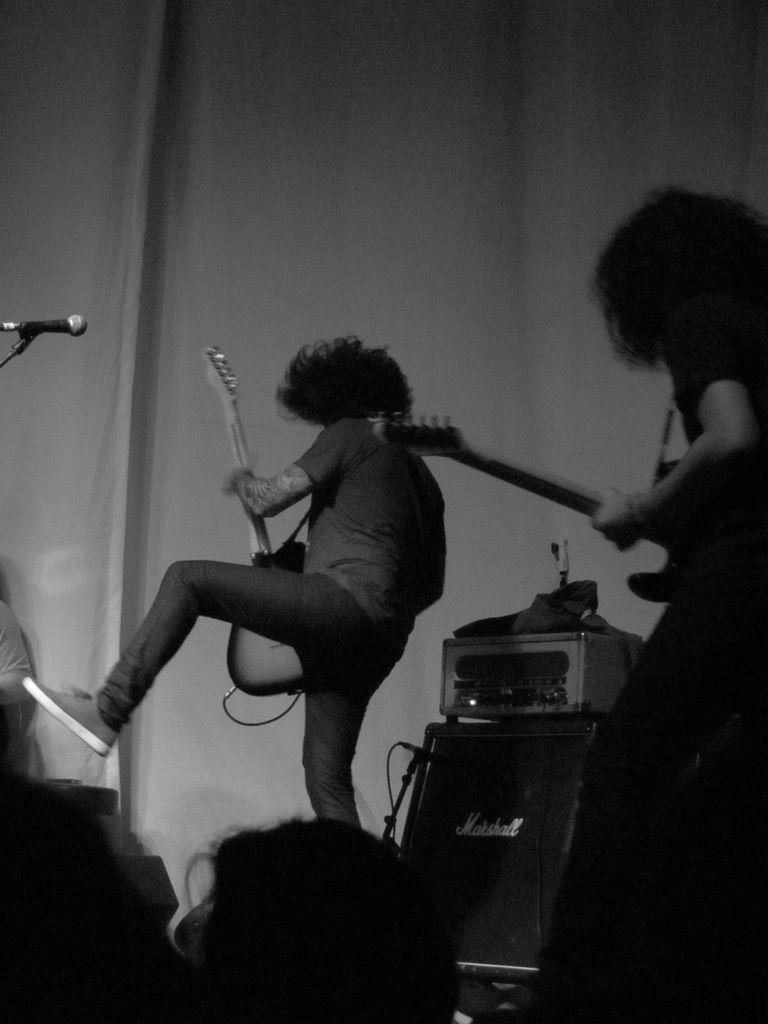Can you describe this image briefly? In this picture, in the middle there is a black color box, There are some people standing and they are holding some music instruments and in the left side there is a microphone in black color, In the background there is a white color wall. 